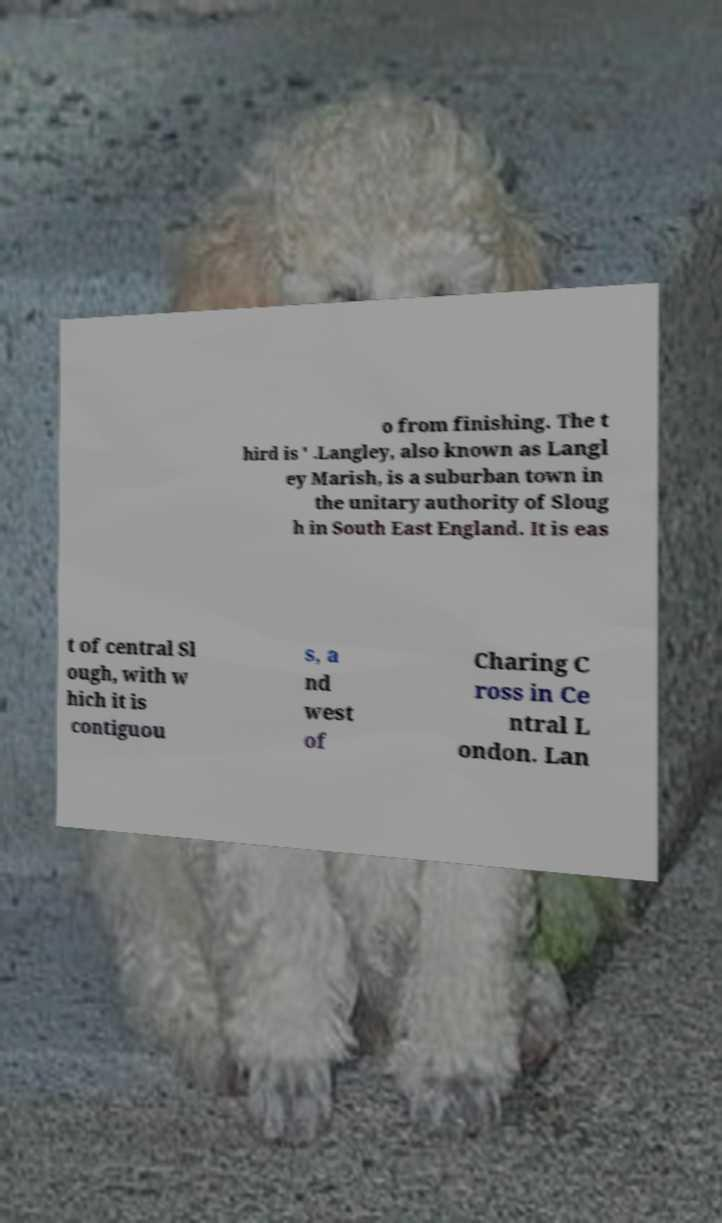Please identify and transcribe the text found in this image. o from finishing. The t hird is ' .Langley, also known as Langl ey Marish, is a suburban town in the unitary authority of Sloug h in South East England. It is eas t of central Sl ough, with w hich it is contiguou s, a nd west of Charing C ross in Ce ntral L ondon. Lan 